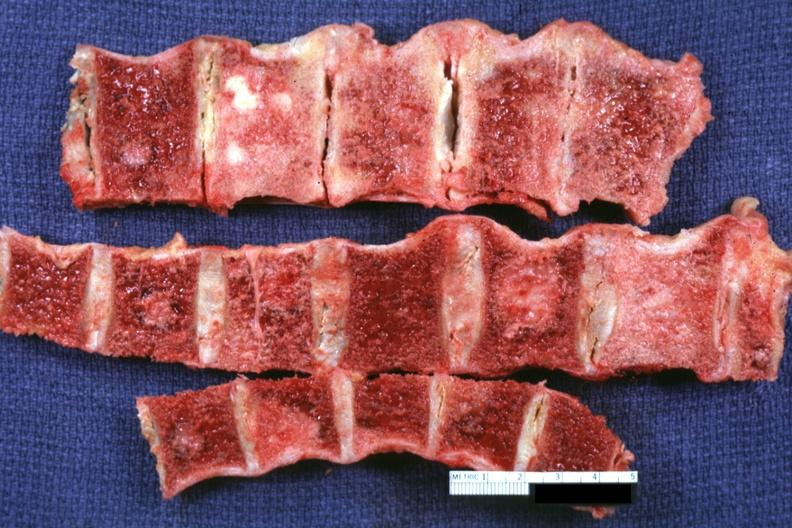how is several segments of vertebral column with easily seen metastatic lesions prostate adenocarcinoma?
Answer the question using a single word or phrase. Primary 